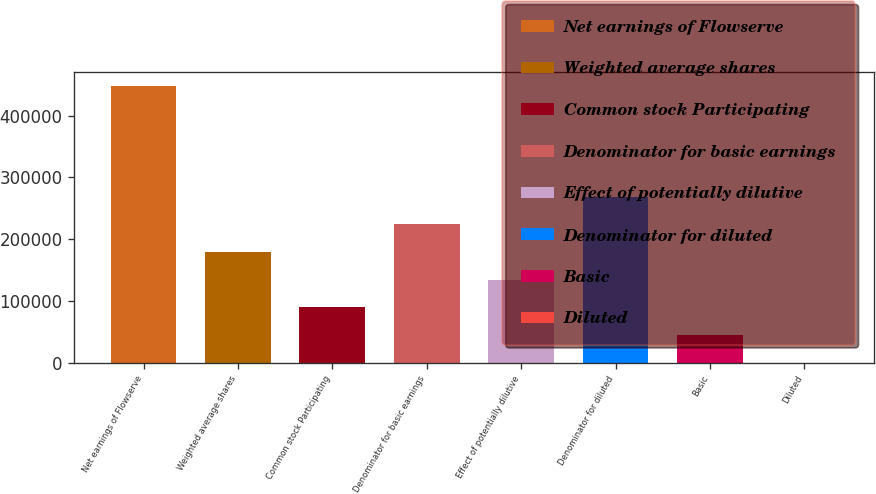<chart> <loc_0><loc_0><loc_500><loc_500><bar_chart><fcel>Net earnings of Flowserve<fcel>Weighted average shares<fcel>Common stock Participating<fcel>Denominator for basic earnings<fcel>Effect of potentially dilutive<fcel>Denominator for diluted<fcel>Basic<fcel>Diluted<nl><fcel>448339<fcel>179341<fcel>89674.6<fcel>224174<fcel>134508<fcel>269007<fcel>44841.6<fcel>8.51<nl></chart> 